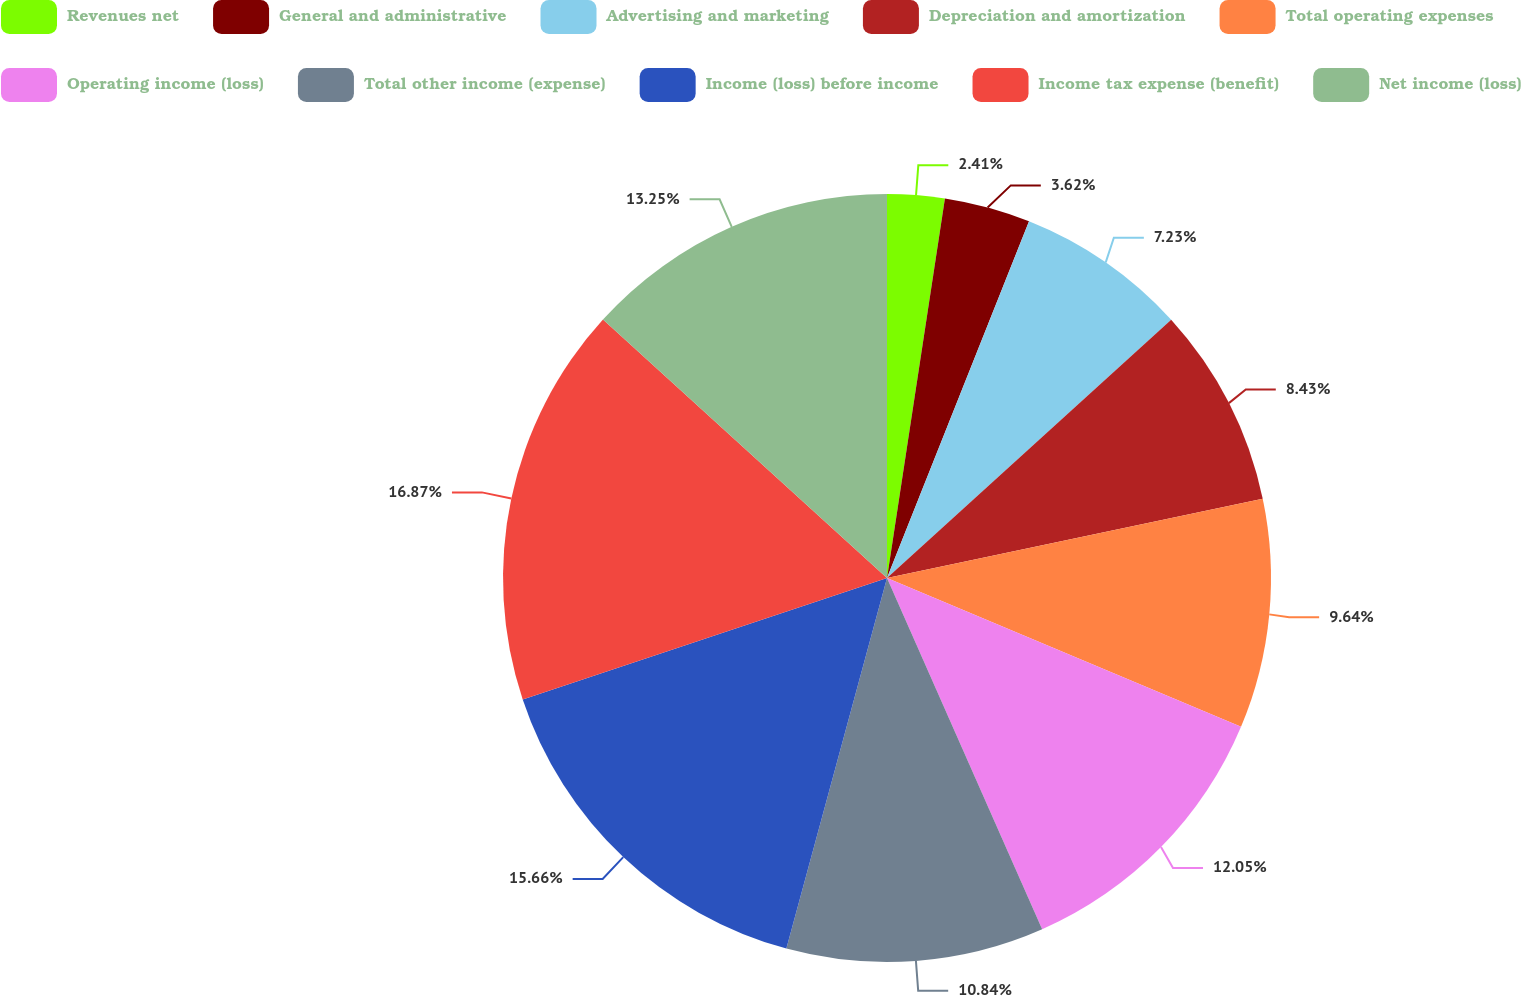Convert chart to OTSL. <chart><loc_0><loc_0><loc_500><loc_500><pie_chart><fcel>Revenues net<fcel>General and administrative<fcel>Advertising and marketing<fcel>Depreciation and amortization<fcel>Total operating expenses<fcel>Operating income (loss)<fcel>Total other income (expense)<fcel>Income (loss) before income<fcel>Income tax expense (benefit)<fcel>Net income (loss)<nl><fcel>2.41%<fcel>3.62%<fcel>7.23%<fcel>8.43%<fcel>9.64%<fcel>12.05%<fcel>10.84%<fcel>15.66%<fcel>16.87%<fcel>13.25%<nl></chart> 